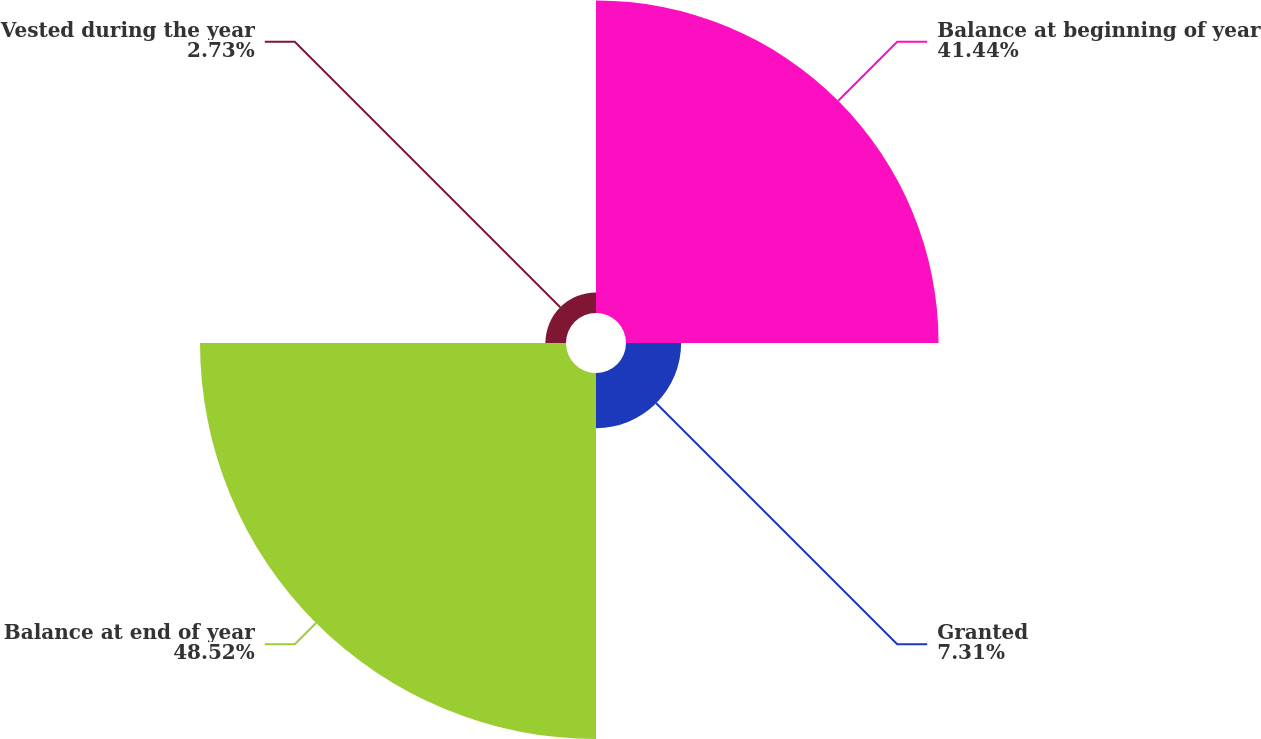Convert chart. <chart><loc_0><loc_0><loc_500><loc_500><pie_chart><fcel>Balance at beginning of year<fcel>Granted<fcel>Balance at end of year<fcel>Vested during the year<nl><fcel>41.44%<fcel>7.31%<fcel>48.52%<fcel>2.73%<nl></chart> 